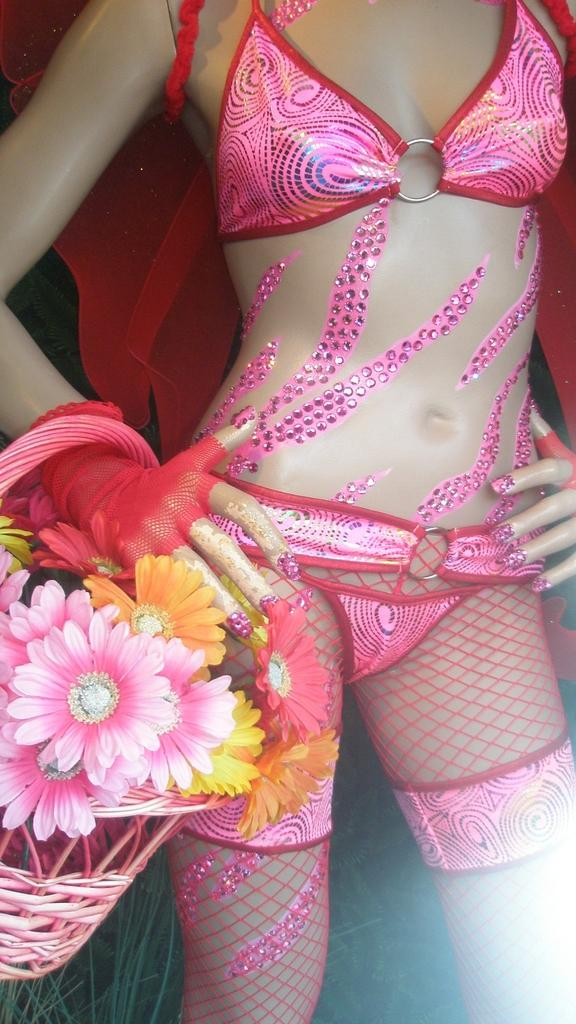What is the main subject of the image? There is a doll in the image. What is the doll wearing? The doll is wearing a pink dress. What is the doll holding in the image? The doll is holding a basket. What can be found inside the basket? The basket contains pink, yellow, and orange flowers. What effect does the crime have on the hydrant in the image? There is no crime or hydrant present in the image; it features a doll holding a basket of flowers. 